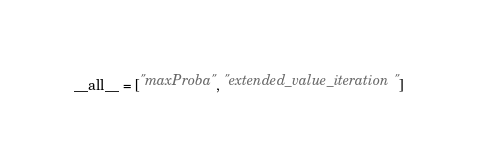Convert code to text. <code><loc_0><loc_0><loc_500><loc_500><_Python_>__all__ = ["maxProba", "extended_value_iteration"]</code> 